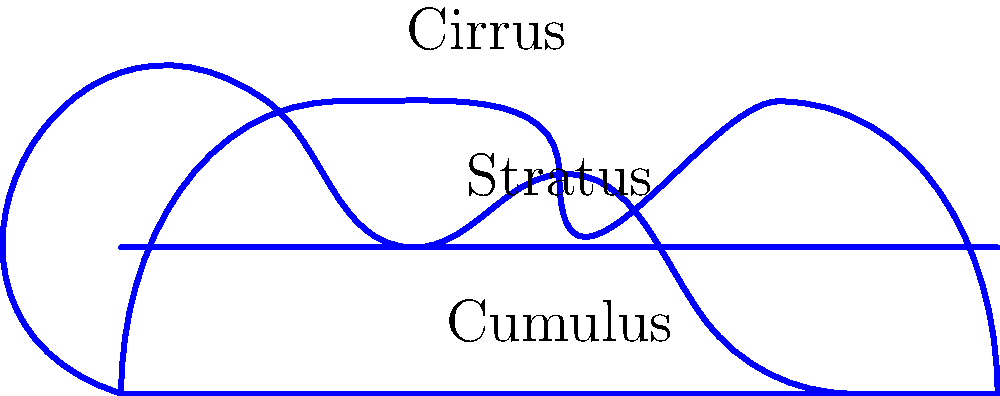In a convolutional neural network (CNN) designed to classify cloud shapes, which layer would be most responsible for identifying the distinct wispy features of cirrus clouds as shown in the image? To understand which layer in a CNN would be most responsible for identifying the distinct wispy features of cirrus clouds, let's break down the process:

1. Input layer: Receives the raw pixel values of the cloud image.

2. Convolutional layers:
   a. Early convolutional layers detect simple features like edges and curves.
   b. Middle convolutional layers combine these simple features to form more complex patterns.
   c. Later convolutional layers identify high-level features specific to cloud types.

3. Pooling layers: Reduce spatial dimensions and make the network more invariant to small translations.

4. Fully connected layers: Combine all features for final classification.

The wispy features of cirrus clouds are complex, high-level features that require a combination of simpler patterns. Therefore, the later convolutional layers would be most responsible for identifying these distinct characteristics.

These layers have:
- Larger receptive fields, allowing them to capture more of the cloud's overall structure.
- More complex feature maps that can represent intricate patterns like the wispy, thread-like appearance of cirrus clouds.
- The ability to combine lower-level features into more meaningful representations specific to cloud types.

While earlier layers are crucial for detecting basic shapes and edges, and fully connected layers make the final classification, it's the later convolutional layers that play the most significant role in identifying the unique features of cirrus clouds.
Answer: Later convolutional layers 